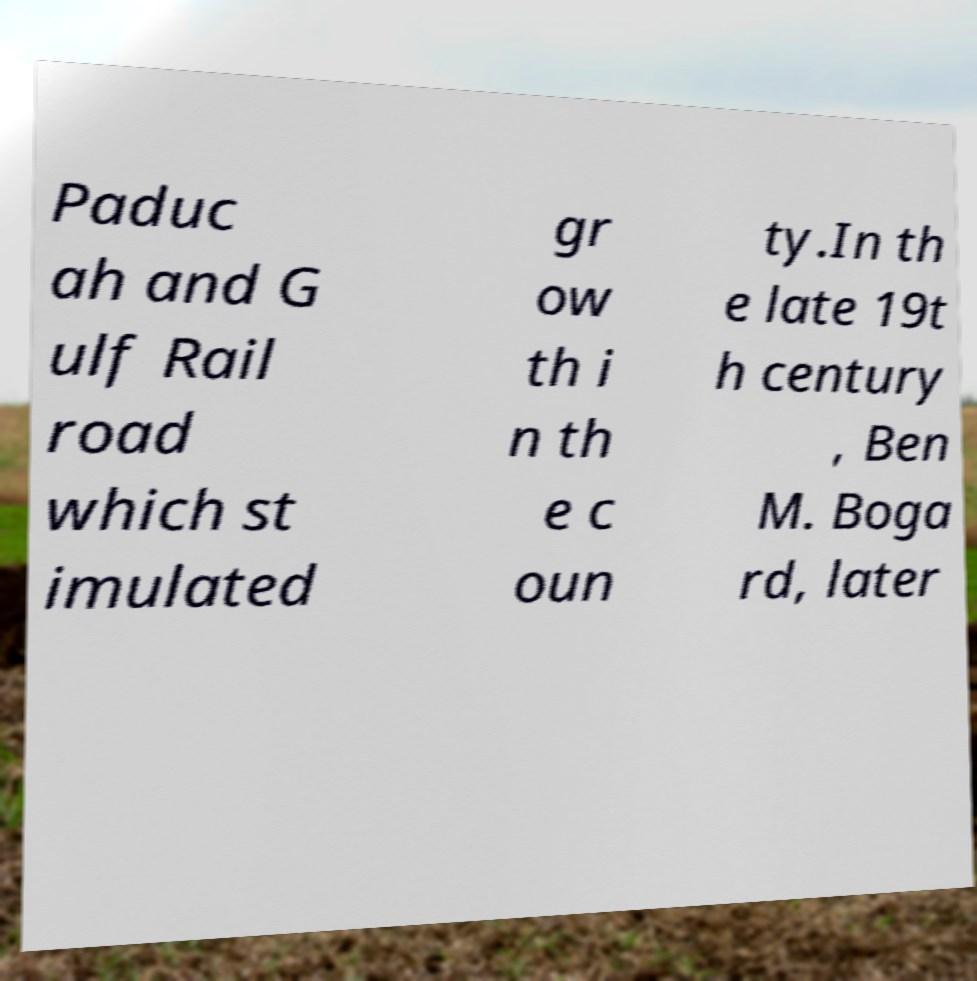What messages or text are displayed in this image? I need them in a readable, typed format. Paduc ah and G ulf Rail road which st imulated gr ow th i n th e c oun ty.In th e late 19t h century , Ben M. Boga rd, later 